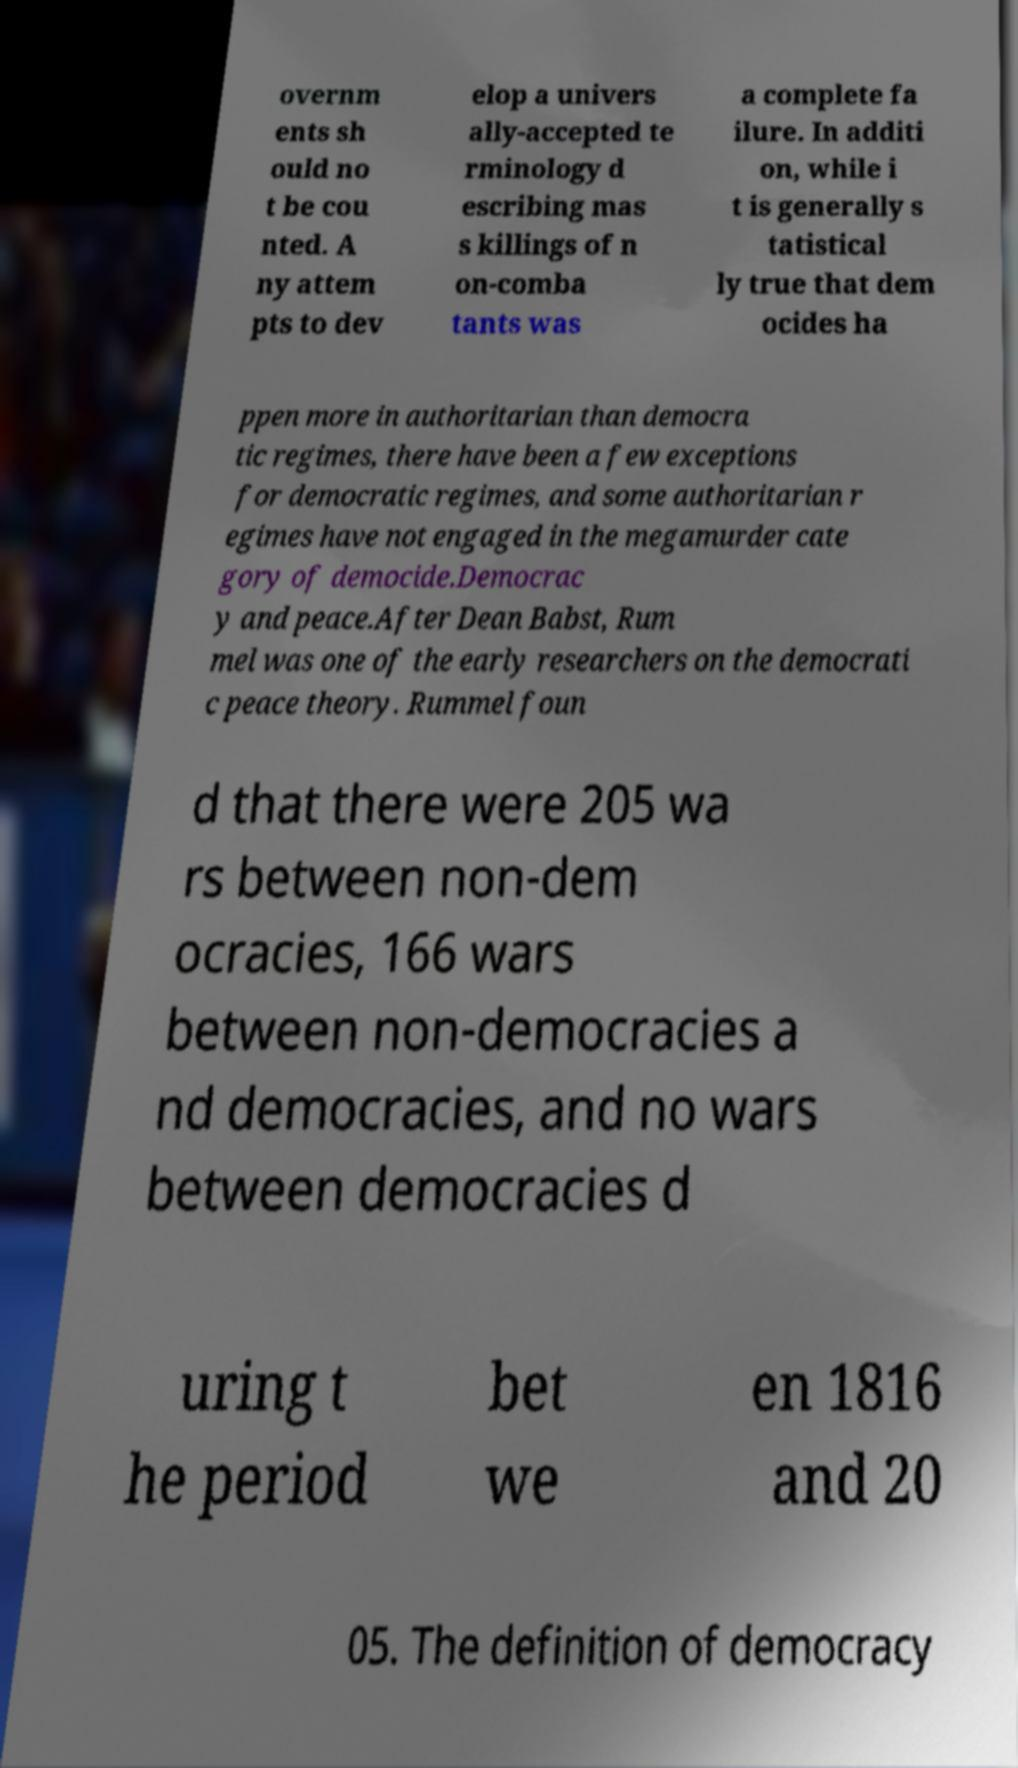Could you assist in decoding the text presented in this image and type it out clearly? overnm ents sh ould no t be cou nted. A ny attem pts to dev elop a univers ally-accepted te rminology d escribing mas s killings of n on-comba tants was a complete fa ilure. In additi on, while i t is generally s tatistical ly true that dem ocides ha ppen more in authoritarian than democra tic regimes, there have been a few exceptions for democratic regimes, and some authoritarian r egimes have not engaged in the megamurder cate gory of democide.Democrac y and peace.After Dean Babst, Rum mel was one of the early researchers on the democrati c peace theory. Rummel foun d that there were 205 wa rs between non-dem ocracies, 166 wars between non-democracies a nd democracies, and no wars between democracies d uring t he period bet we en 1816 and 20 05. The definition of democracy 